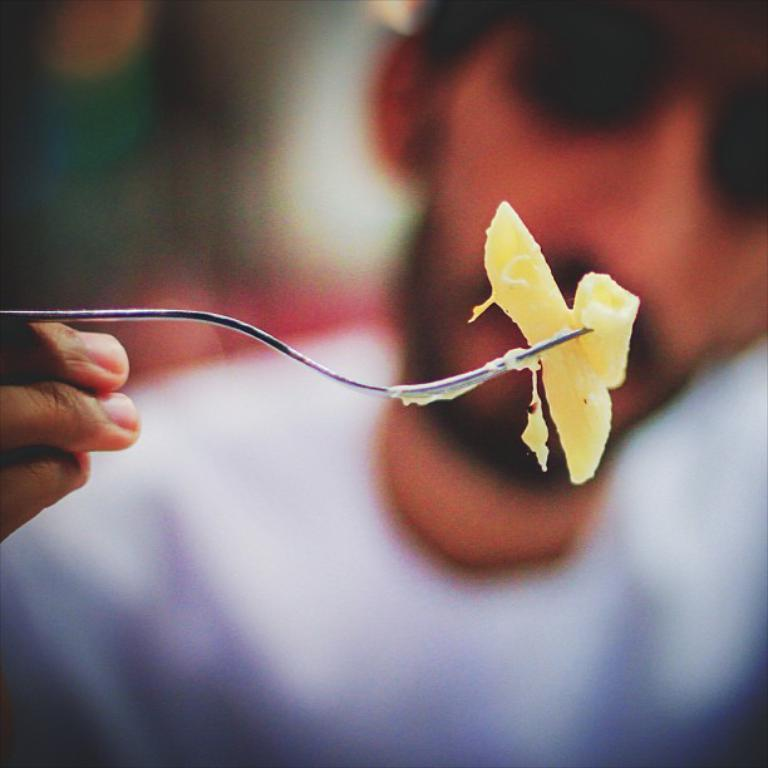What is the main subject of the image? There is a person in the image. What is the person doing in the image? The person is holding a food item with a fork. Can you describe the background of the image? The background of the image is dark. What type of work is the person doing in the image? The image does not show the person performing any work-related tasks. 